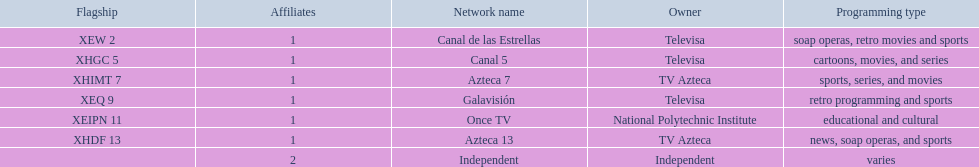How many affiliates does galavision have? 1. 